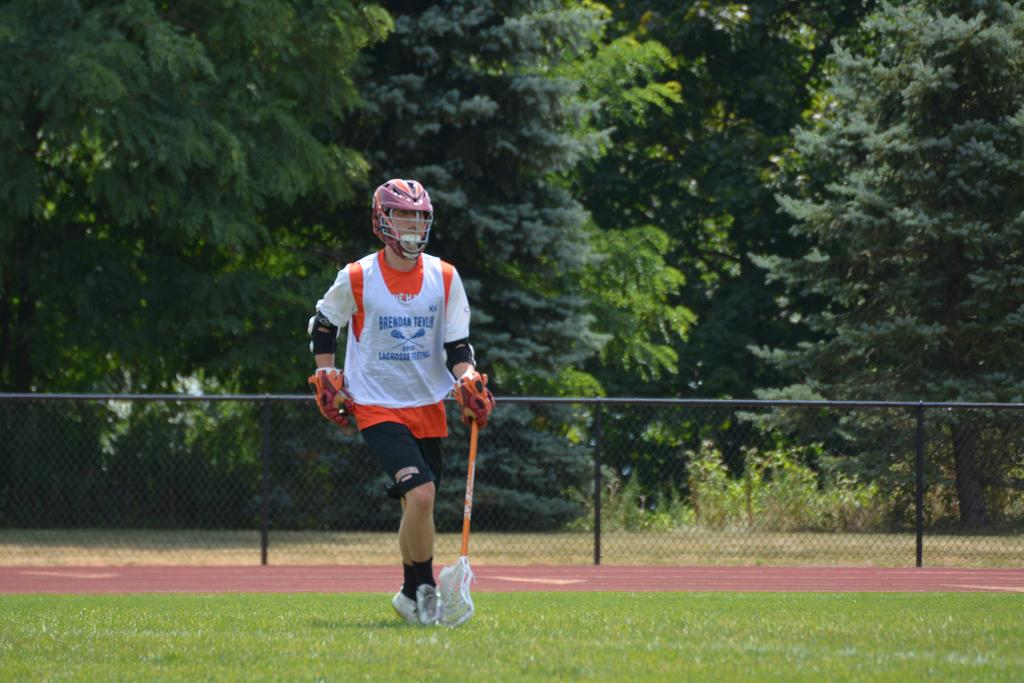Provide a one-sentence caption for the provided image. A lacrosse player named Brendan Teylor runs down the field holding his lacrosse stick. 